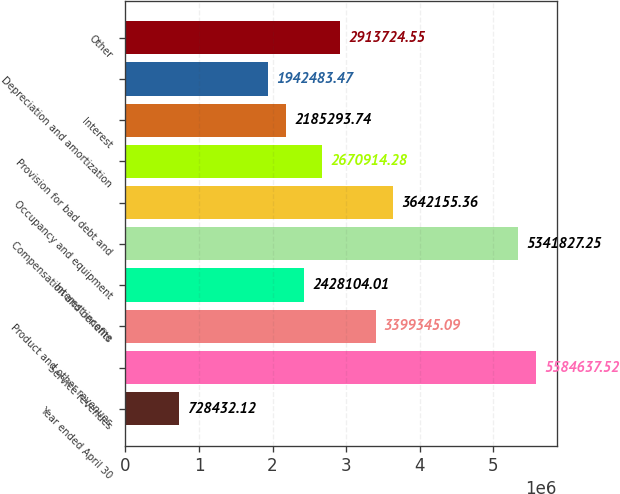Convert chart to OTSL. <chart><loc_0><loc_0><loc_500><loc_500><bar_chart><fcel>Year ended April 30<fcel>Service revenues<fcel>Product and other revenues<fcel>Interest income<fcel>Compensation and benefits<fcel>Occupancy and equipment<fcel>Provision for bad debt and<fcel>Interest<fcel>Depreciation and amortization<fcel>Other<nl><fcel>728432<fcel>5.58464e+06<fcel>3.39935e+06<fcel>2.4281e+06<fcel>5.34183e+06<fcel>3.64216e+06<fcel>2.67091e+06<fcel>2.18529e+06<fcel>1.94248e+06<fcel>2.91372e+06<nl></chart> 